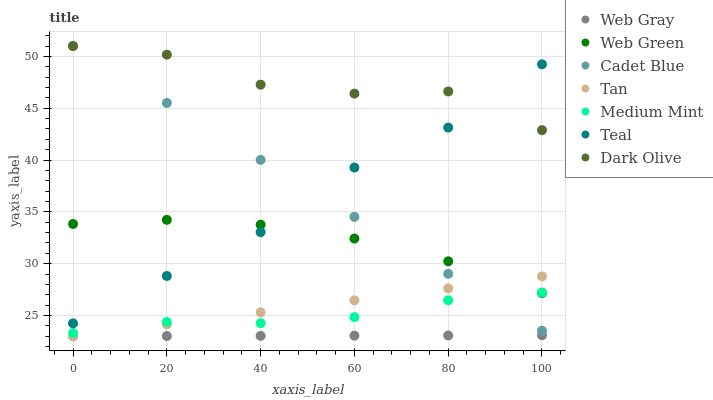Does Web Gray have the minimum area under the curve?
Answer yes or no. Yes. Does Dark Olive have the maximum area under the curve?
Answer yes or no. Yes. Does Cadet Blue have the minimum area under the curve?
Answer yes or no. No. Does Cadet Blue have the maximum area under the curve?
Answer yes or no. No. Is Web Gray the smoothest?
Answer yes or no. Yes. Is Dark Olive the roughest?
Answer yes or no. Yes. Is Cadet Blue the smoothest?
Answer yes or no. No. Is Cadet Blue the roughest?
Answer yes or no. No. Does Web Gray have the lowest value?
Answer yes or no. Yes. Does Cadet Blue have the lowest value?
Answer yes or no. No. Does Dark Olive have the highest value?
Answer yes or no. Yes. Does Web Green have the highest value?
Answer yes or no. No. Is Web Gray less than Teal?
Answer yes or no. Yes. Is Dark Olive greater than Web Gray?
Answer yes or no. Yes. Does Medium Mint intersect Cadet Blue?
Answer yes or no. Yes. Is Medium Mint less than Cadet Blue?
Answer yes or no. No. Is Medium Mint greater than Cadet Blue?
Answer yes or no. No. Does Web Gray intersect Teal?
Answer yes or no. No. 